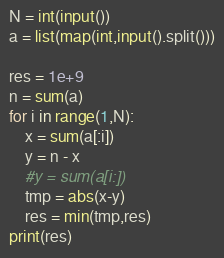<code> <loc_0><loc_0><loc_500><loc_500><_Python_>N = int(input())
a = list(map(int,input().split()))

res = 1e+9
n = sum(a)
for i in range(1,N):
    x = sum(a[:i])
    y = n - x
    #y = sum(a[i:])
    tmp = abs(x-y)
    res = min(tmp,res)
print(res)</code> 